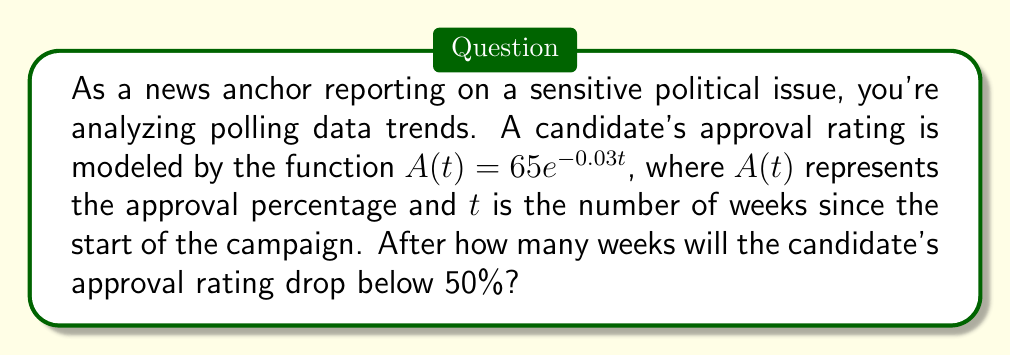Help me with this question. To solve this problem, we need to follow these steps:

1) We want to find when $A(t) < 50$. So, we set up the inequality:

   $65e^{-0.03t} < 50$

2) Divide both sides by 65:

   $e^{-0.03t} < \frac{50}{65}$

3) Take the natural logarithm of both sides. Remember, $\ln(e^x) = x$:

   $-0.03t < \ln(\frac{50}{65})$

4) Divide both sides by -0.03. Note that the inequality sign flips when we divide by a negative number:

   $t > -\frac{\ln(\frac{50}{65})}{0.03}$

5) Now, let's calculate this:
   
   $\ln(\frac{50}{65}) \approx -0.2623$
   
   $t > \frac{0.2623}{0.03} \approx 8.74$

6) Since we're looking for the number of weeks, and we can't have a partial week in this context, we need to round up to the next whole number.
Answer: The candidate's approval rating will drop below 50% after 9 weeks. 